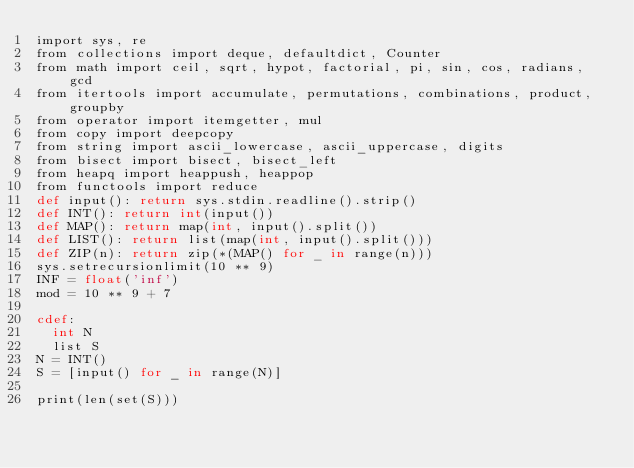Convert code to text. <code><loc_0><loc_0><loc_500><loc_500><_Cython_>import sys, re
from collections import deque, defaultdict, Counter
from math import ceil, sqrt, hypot, factorial, pi, sin, cos, radians, gcd
from itertools import accumulate, permutations, combinations, product, groupby
from operator import itemgetter, mul
from copy import deepcopy
from string import ascii_lowercase, ascii_uppercase, digits
from bisect import bisect, bisect_left
from heapq import heappush, heappop
from functools import reduce
def input(): return sys.stdin.readline().strip()
def INT(): return int(input())
def MAP(): return map(int, input().split())
def LIST(): return list(map(int, input().split()))
def ZIP(n): return zip(*(MAP() for _ in range(n)))
sys.setrecursionlimit(10 ** 9)
INF = float('inf')
mod = 10 ** 9 + 7

cdef:
	int N
	list S
N = INT()
S = [input() for _ in range(N)]

print(len(set(S)))
</code> 